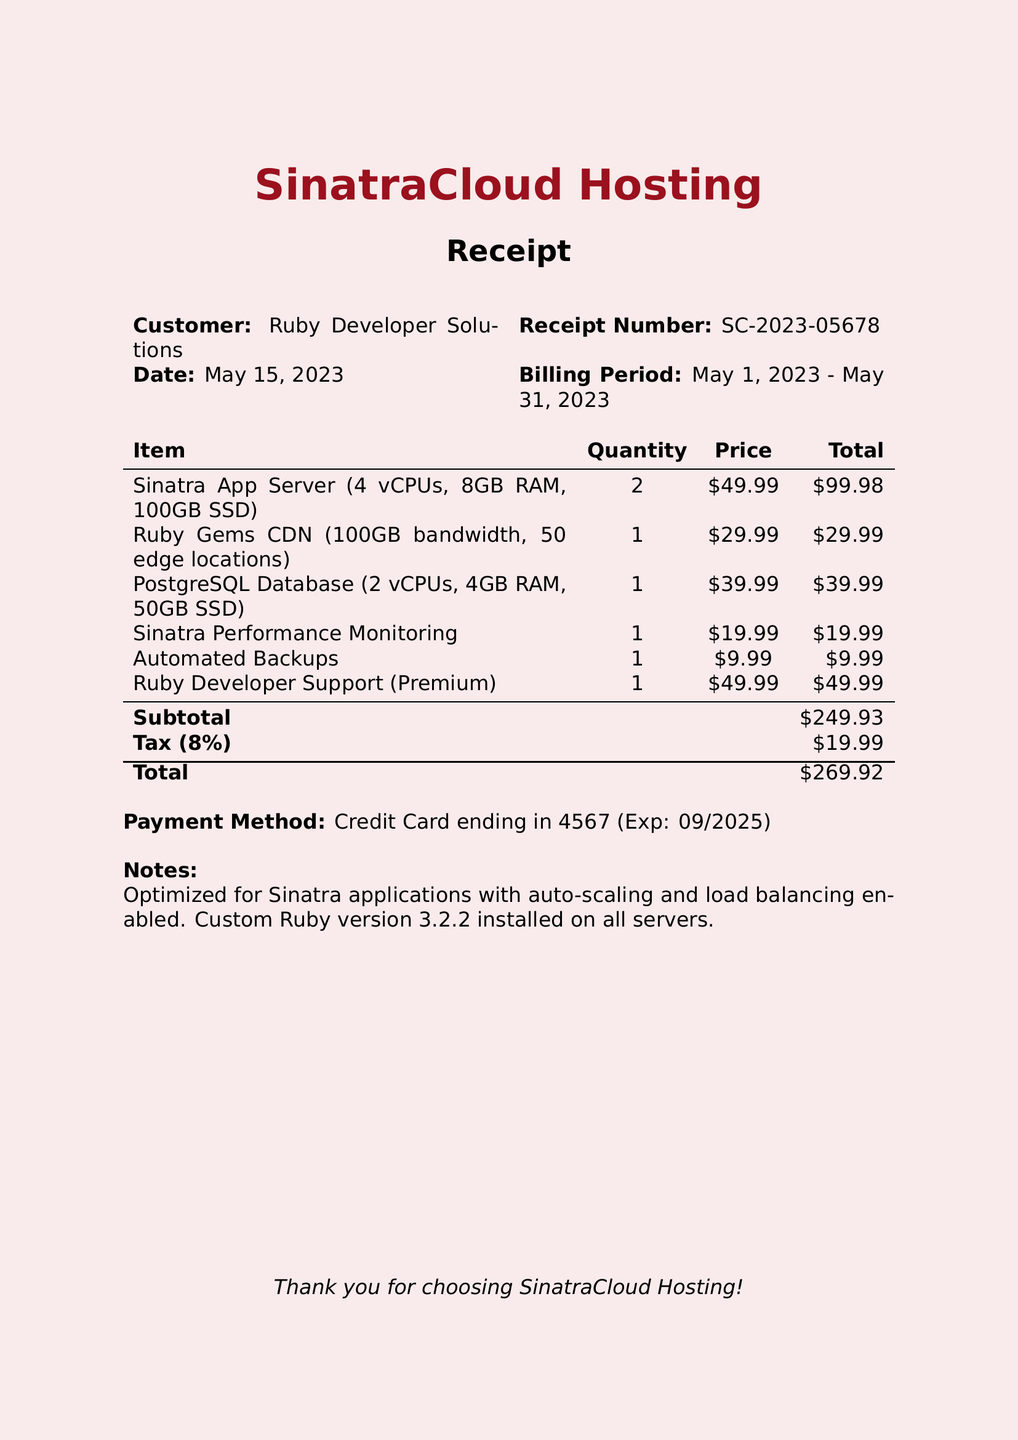What is the company name? The company name is stated at the top of the receipt.
Answer: SinatraCloud Hosting Who is the customer? The customer is mentioned right after the company name in the receipt.
Answer: Ruby Developer Solutions What is the receipt number? The receipt number is provided for tracking purposes and can be found below the customer name.
Answer: SC-2023-05678 What is the billing period? The billing period is clearly indicated, showing the time frame covered by the receipt.
Answer: May 1, 2023 - May 31, 2023 What is the total amount billed? The total amount is calculated at the bottom of the receipt, including subtotal, tax, etc.
Answer: 269.92 How many Sinatra App Servers are included? The quantity of Sinatra App Servers is listed next to the item description in the receipt.
Answer: 2 What support plan is included? The support plan is described along with its level and benefits.
Answer: Ruby Developer Support What is the tax rate applied? The tax rate is specified somewhere under the subtotal on the receipt.
Answer: 8% What type of payment was used? The payment method is mentioned towards the end of the receipt.
Answer: Credit Card What notes are included in the receipt? The notes section provides additional information regarding the service; it is written at the bottom of the receipt.
Answer: Optimized for Sinatra applications with auto-scaling and load balancing enabled. Custom Ruby version 3.2.2 installed on all servers 